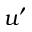<formula> <loc_0><loc_0><loc_500><loc_500>u ^ { \prime }</formula> 